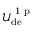<formula> <loc_0><loc_0><loc_500><loc_500>\mathcal { U } _ { d e } ^ { 1 p }</formula> 